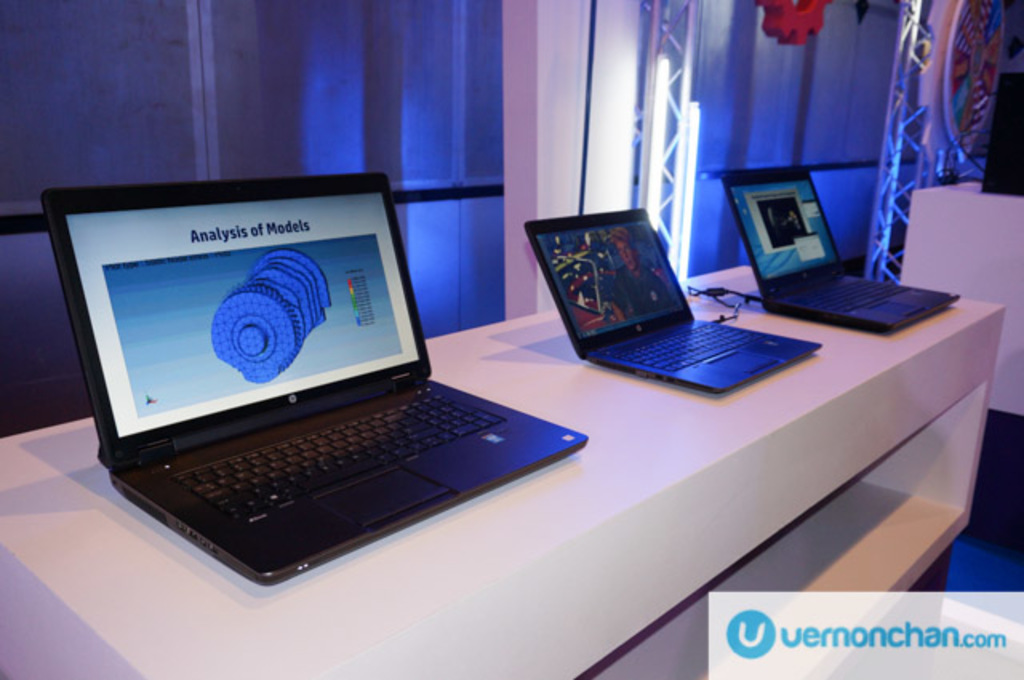What types of software might be running on these laptops? The laptops appear to be demonstrating specialized software for 3D modeling and analysis, possibly for educational or professional presentations at a tech expo. Are these laptops likely to be high-performance models? Yes, the detailed 3D modeling and analysis software displayed suggests these are high-performance laptops capable of handling compute-intensive tasks. 